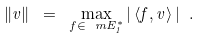<formula> <loc_0><loc_0><loc_500><loc_500>\| v \| \ = \ \max _ { f \in \ m E ^ { * } _ { 1 } } | \left \langle f , v \right \rangle | \ .</formula> 